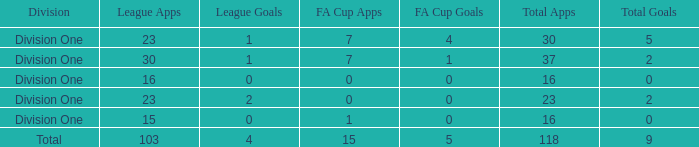The total goals have a fa cup games more than 1, and a total games of 37, and a league games fewer than 30?, what is the total figure? 0.0. 